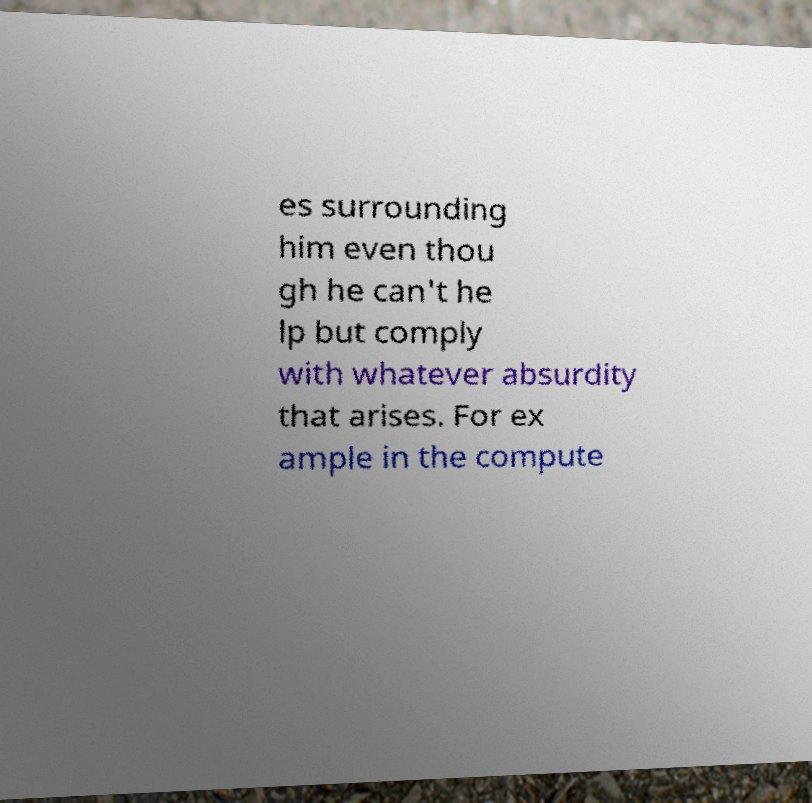What messages or text are displayed in this image? I need them in a readable, typed format. es surrounding him even thou gh he can't he lp but comply with whatever absurdity that arises. For ex ample in the compute 